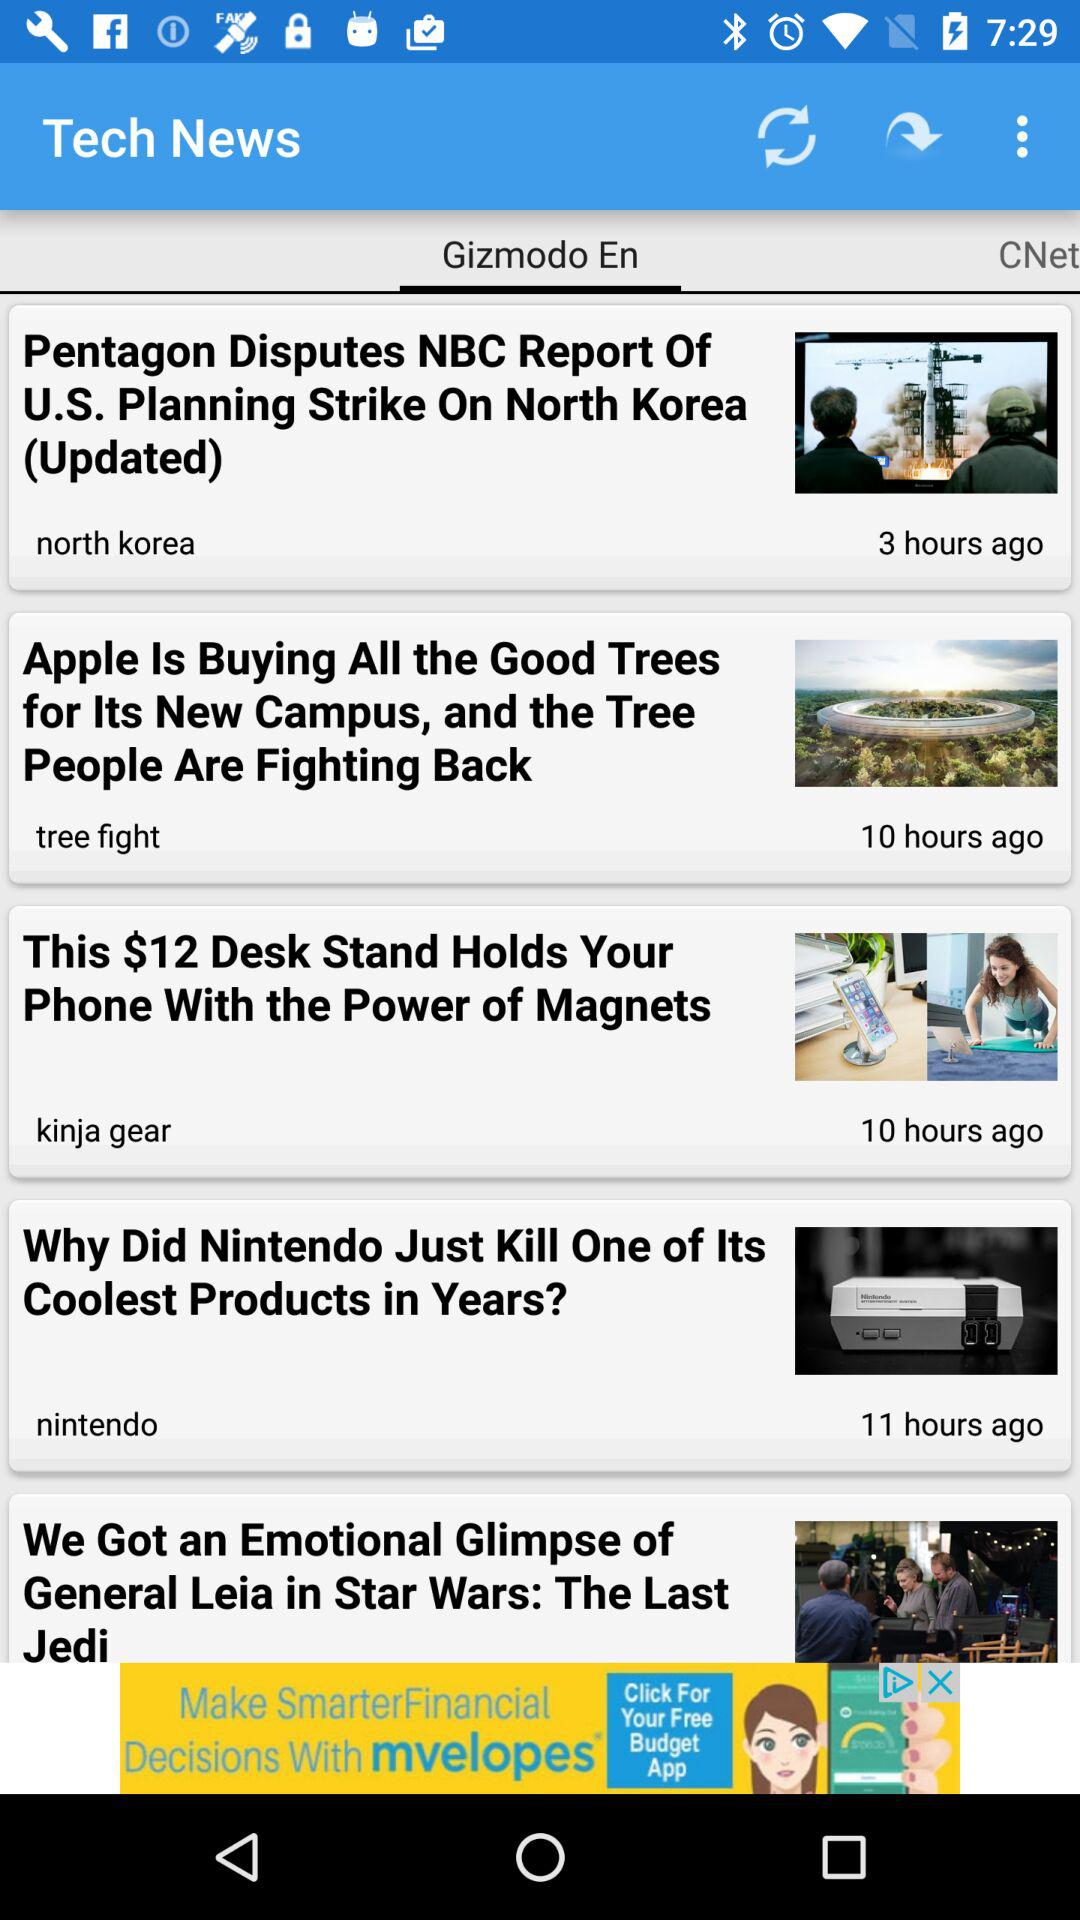When was the news of the tree fight updated? The news was updated 10 hours ago. 